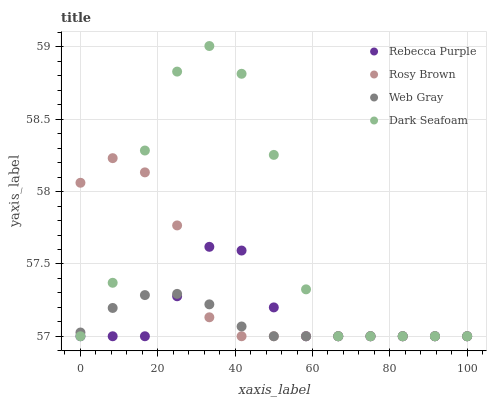Does Web Gray have the minimum area under the curve?
Answer yes or no. Yes. Does Dark Seafoam have the maximum area under the curve?
Answer yes or no. Yes. Does Rosy Brown have the minimum area under the curve?
Answer yes or no. No. Does Rosy Brown have the maximum area under the curve?
Answer yes or no. No. Is Web Gray the smoothest?
Answer yes or no. Yes. Is Dark Seafoam the roughest?
Answer yes or no. Yes. Is Rosy Brown the smoothest?
Answer yes or no. No. Is Rosy Brown the roughest?
Answer yes or no. No. Does Dark Seafoam have the lowest value?
Answer yes or no. Yes. Does Dark Seafoam have the highest value?
Answer yes or no. Yes. Does Rosy Brown have the highest value?
Answer yes or no. No. Does Dark Seafoam intersect Rosy Brown?
Answer yes or no. Yes. Is Dark Seafoam less than Rosy Brown?
Answer yes or no. No. Is Dark Seafoam greater than Rosy Brown?
Answer yes or no. No. 